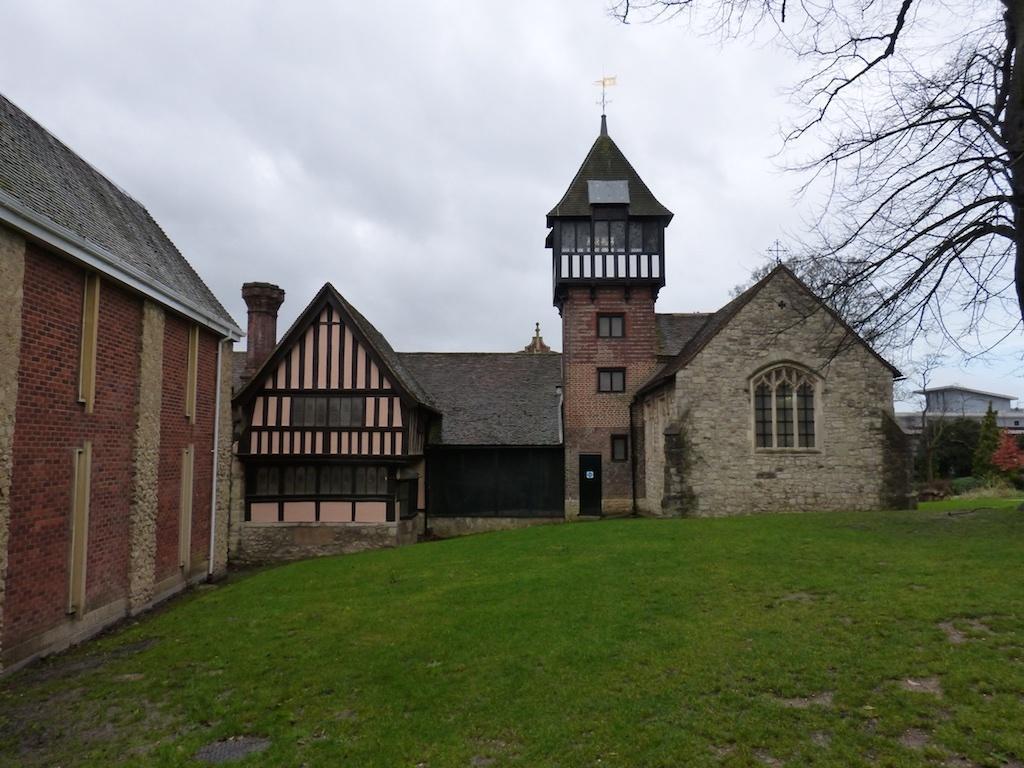Can you describe this image briefly? In this image I can see houses and trees ,grass and at the top I can see the sky. 